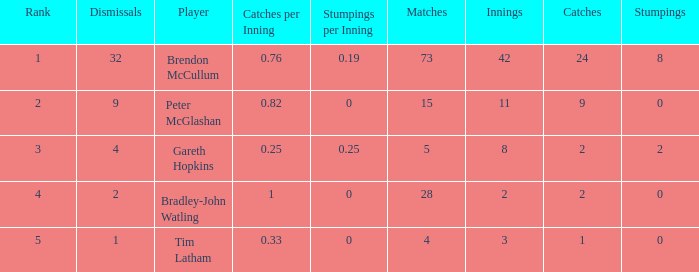Could you help me parse every detail presented in this table? {'header': ['Rank', 'Dismissals', 'Player', 'Catches per Inning', 'Stumpings per Inning', 'Matches', 'Innings', 'Catches', 'Stumpings'], 'rows': [['1', '32', 'Brendon McCullum', '0.76', '0.19', '73', '42', '24', '8'], ['2', '9', 'Peter McGlashan', '0.82', '0', '15', '11', '9', '0'], ['3', '4', 'Gareth Hopkins', '0.25', '0.25', '5', '8', '2', '2'], ['4', '2', 'Bradley-John Watling', '1', '0', '28', '2', '2', '0'], ['5', '1', 'Tim Latham', '0.33', '0', '4', '3', '1', '0']]} How many innings had a total of 2 catches and 0 stumpings? 1.0. 